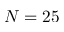<formula> <loc_0><loc_0><loc_500><loc_500>N = 2 5</formula> 